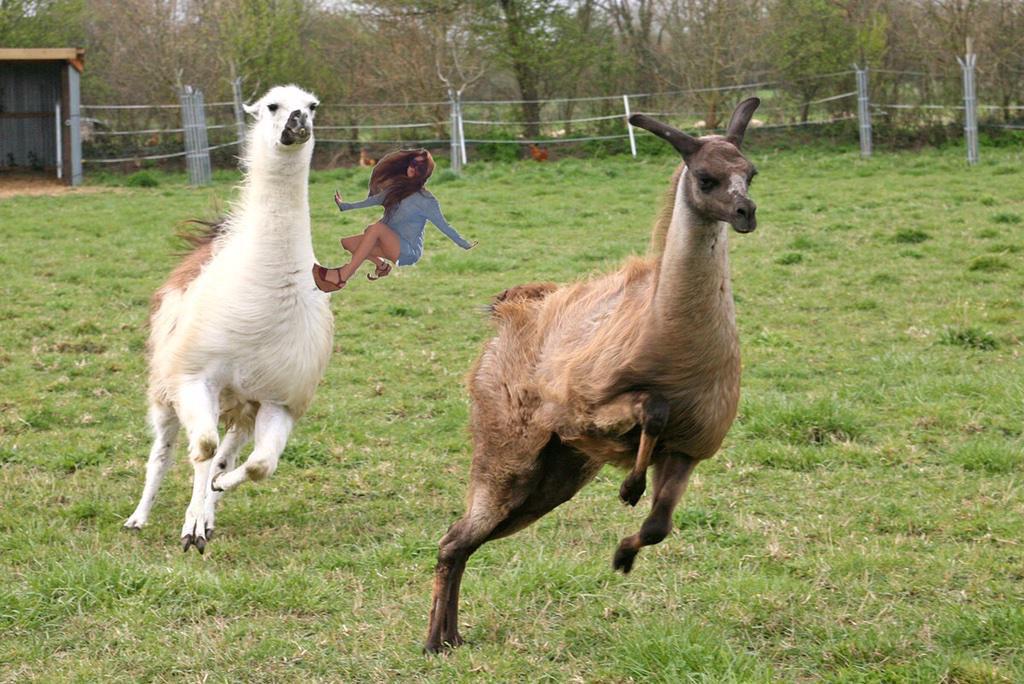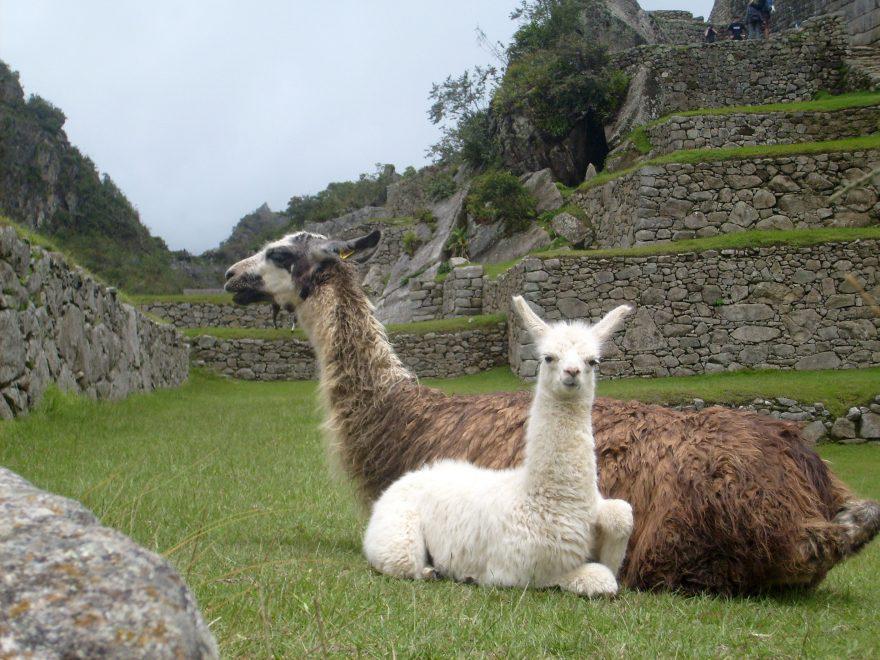The first image is the image on the left, the second image is the image on the right. Analyze the images presented: Is the assertion "Each image shows a pair of llamas in the foreground, and at least one pair includes a white llama and a brownish llama." valid? Answer yes or no. Yes. 